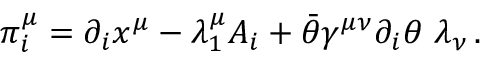Convert formula to latex. <formula><loc_0><loc_0><loc_500><loc_500>\pi _ { i } ^ { \mu } = \partial _ { i } x ^ { \mu } - \lambda _ { 1 } ^ { \mu } A _ { i } + \bar { \theta } \gamma ^ { \mu \nu } \partial _ { i } \theta \, \lambda _ { \nu } \, .</formula> 